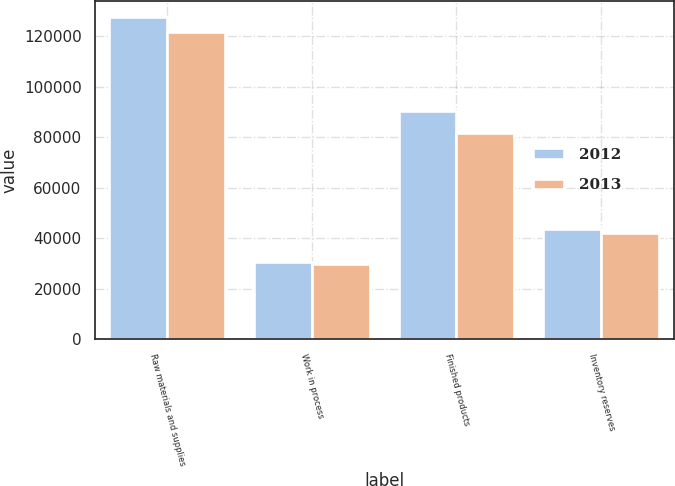Convert chart to OTSL. <chart><loc_0><loc_0><loc_500><loc_500><stacked_bar_chart><ecel><fcel>Raw materials and supplies<fcel>Work in process<fcel>Finished products<fcel>Inventory reserves<nl><fcel>2012<fcel>127525<fcel>30498<fcel>90352<fcel>43452<nl><fcel>2013<fcel>121573<fcel>29725<fcel>81536<fcel>41967<nl></chart> 